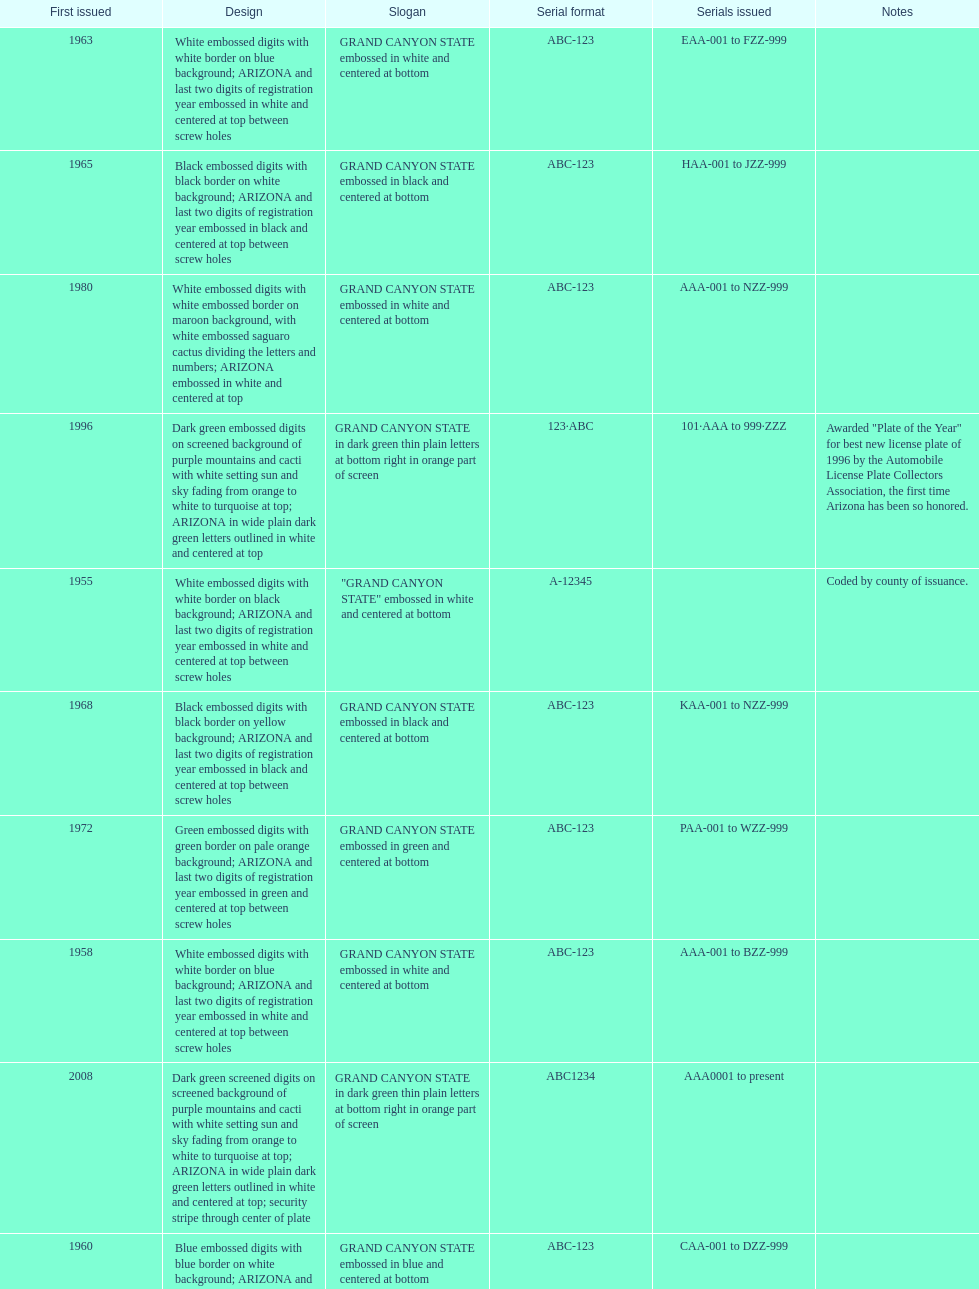Which year featured the license plate with the least characters? 1955. Can you give me this table as a dict? {'header': ['First issued', 'Design', 'Slogan', 'Serial format', 'Serials issued', 'Notes'], 'rows': [['1963', 'White embossed digits with white border on blue background; ARIZONA and last two digits of registration year embossed in white and centered at top between screw holes', 'GRAND CANYON STATE embossed in white and centered at bottom', 'ABC-123', 'EAA-001 to FZZ-999', ''], ['1965', 'Black embossed digits with black border on white background; ARIZONA and last two digits of registration year embossed in black and centered at top between screw holes', 'GRAND CANYON STATE embossed in black and centered at bottom', 'ABC-123', 'HAA-001 to JZZ-999', ''], ['1980', 'White embossed digits with white embossed border on maroon background, with white embossed saguaro cactus dividing the letters and numbers; ARIZONA embossed in white and centered at top', 'GRAND CANYON STATE embossed in white and centered at bottom', 'ABC-123', 'AAA-001 to NZZ-999', ''], ['1996', 'Dark green embossed digits on screened background of purple mountains and cacti with white setting sun and sky fading from orange to white to turquoise at top; ARIZONA in wide plain dark green letters outlined in white and centered at top', 'GRAND CANYON STATE in dark green thin plain letters at bottom right in orange part of screen', '123·ABC', '101·AAA to 999·ZZZ', 'Awarded "Plate of the Year" for best new license plate of 1996 by the Automobile License Plate Collectors Association, the first time Arizona has been so honored.'], ['1955', 'White embossed digits with white border on black background; ARIZONA and last two digits of registration year embossed in white and centered at top between screw holes', '"GRAND CANYON STATE" embossed in white and centered at bottom', 'A-12345', '', 'Coded by county of issuance.'], ['1968', 'Black embossed digits with black border on yellow background; ARIZONA and last two digits of registration year embossed in black and centered at top between screw holes', 'GRAND CANYON STATE embossed in black and centered at bottom', 'ABC-123', 'KAA-001 to NZZ-999', ''], ['1972', 'Green embossed digits with green border on pale orange background; ARIZONA and last two digits of registration year embossed in green and centered at top between screw holes', 'GRAND CANYON STATE embossed in green and centered at bottom', 'ABC-123', 'PAA-001 to WZZ-999', ''], ['1958', 'White embossed digits with white border on blue background; ARIZONA and last two digits of registration year embossed in white and centered at top between screw holes', 'GRAND CANYON STATE embossed in white and centered at bottom', 'ABC-123', 'AAA-001 to BZZ-999', ''], ['2008', 'Dark green screened digits on screened background of purple mountains and cacti with white setting sun and sky fading from orange to white to turquoise at top; ARIZONA in wide plain dark green letters outlined in white and centered at top; security stripe through center of plate', 'GRAND CANYON STATE in dark green thin plain letters at bottom right in orange part of screen', 'ABC1234', 'AAA0001 to present', ''], ['1960', 'Blue embossed digits with blue border on white background; ARIZONA and last two digits of registration year embossed in blue and centered at top between screw holes', 'GRAND CANYON STATE embossed in blue and centered at bottom', 'ABC-123', 'CAA-001 to DZZ-999', '']]} 